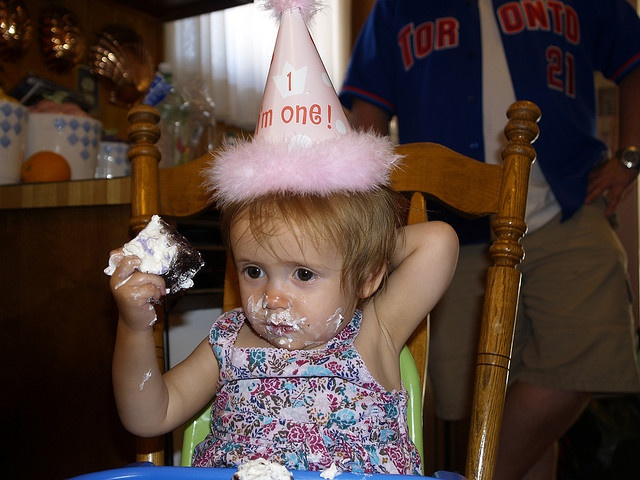Describe the objects in this image and their specific colors. I can see people in black, maroon, and gray tones, people in black, gray, lavender, and darkgray tones, chair in black, maroon, and olive tones, cake in black, lightgray, darkgray, and gray tones, and bottle in black and gray tones in this image. 